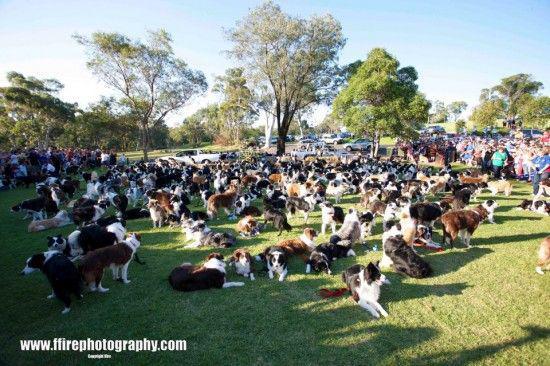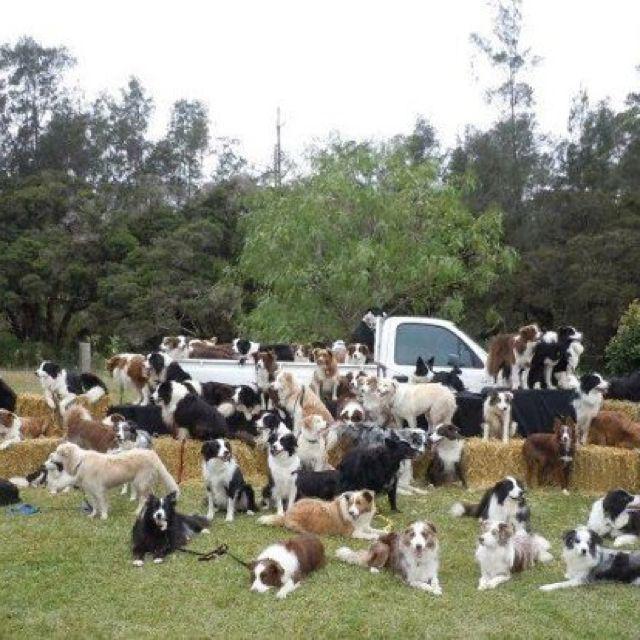The first image is the image on the left, the second image is the image on the right. Assess this claim about the two images: "There are exactly seven dogs in the image on the right.". Correct or not? Answer yes or no. No. 